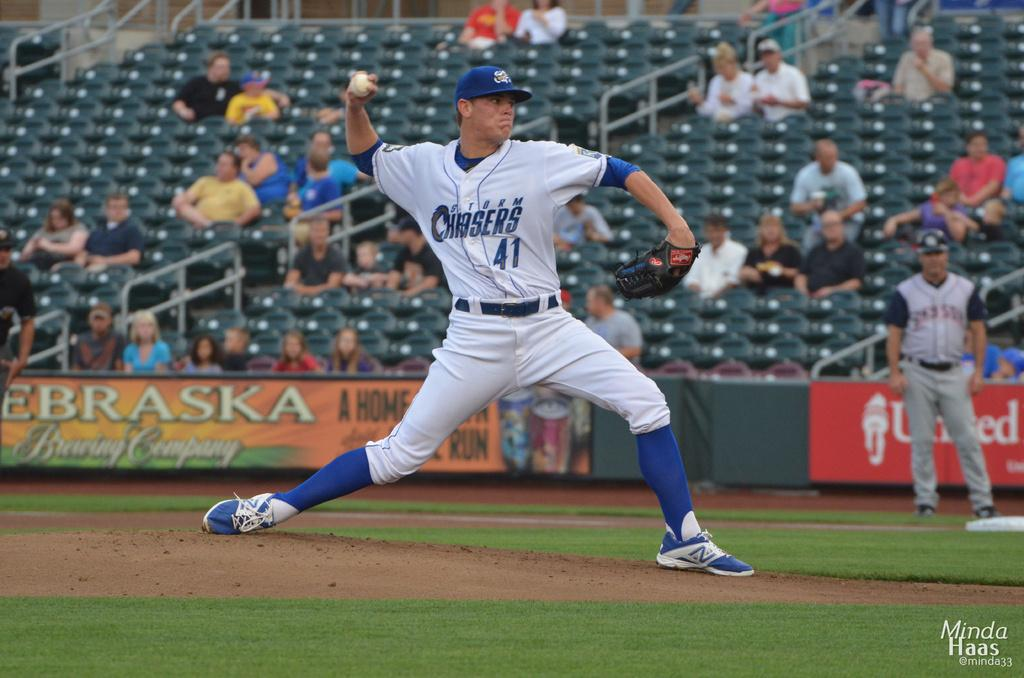<image>
Provide a brief description of the given image. The pitcher for the Storm Chasers is number 41 and is about to throw the ball. 